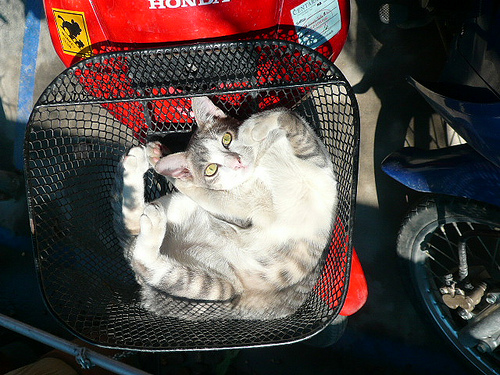<image>Who is riding the bicycle? I don't know who is riding the bicycle. It could be a cat, a person, or no one. Who is riding the bicycle? I am not sure who is riding the bicycle. It can be either a person or a cat. 